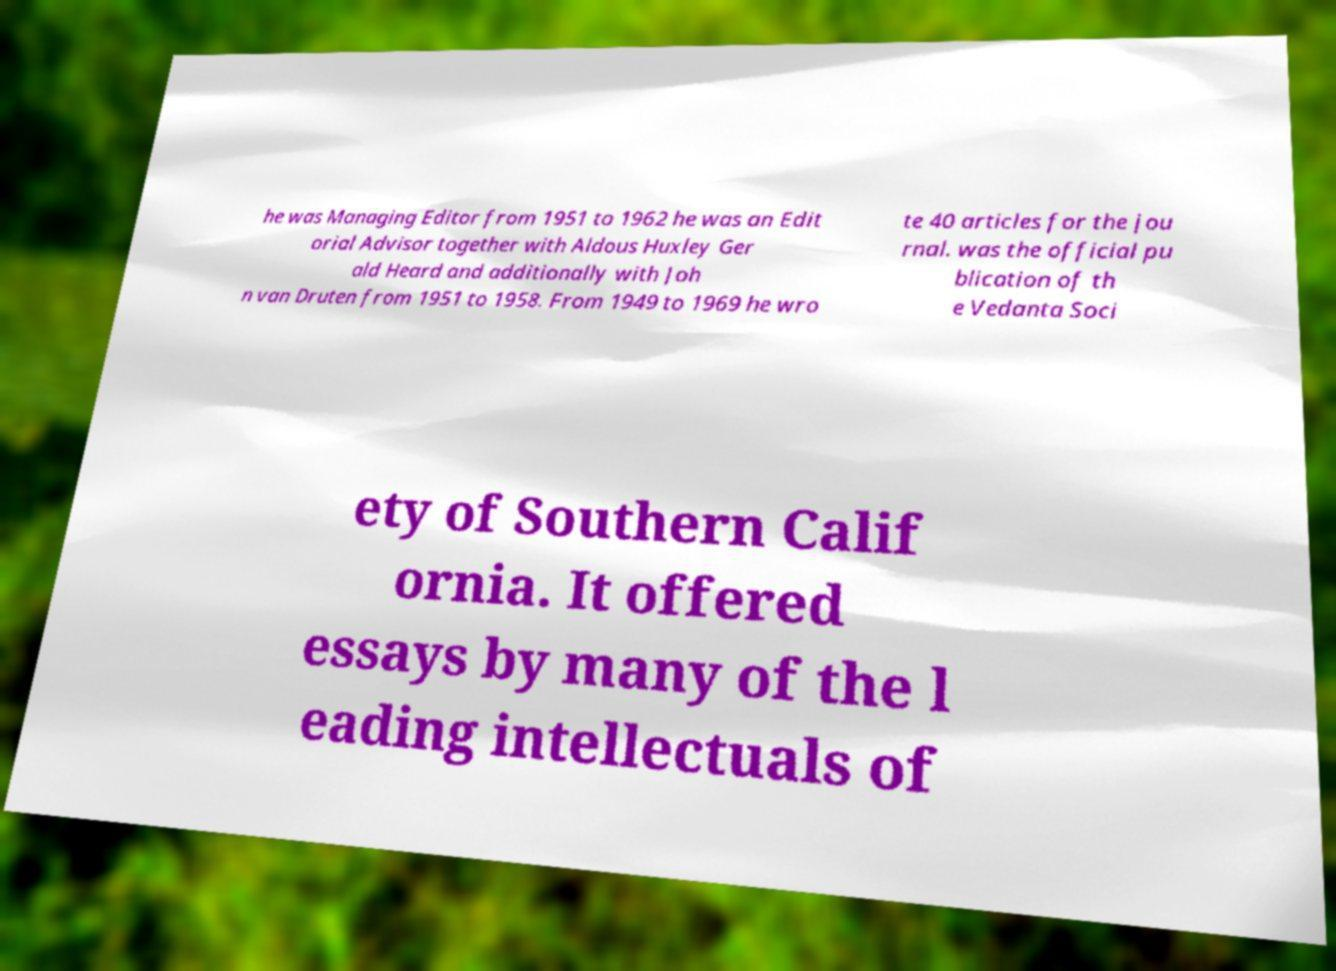Please identify and transcribe the text found in this image. he was Managing Editor from 1951 to 1962 he was an Edit orial Advisor together with Aldous Huxley Ger ald Heard and additionally with Joh n van Druten from 1951 to 1958. From 1949 to 1969 he wro te 40 articles for the jou rnal. was the official pu blication of th e Vedanta Soci ety of Southern Calif ornia. It offered essays by many of the l eading intellectuals of 